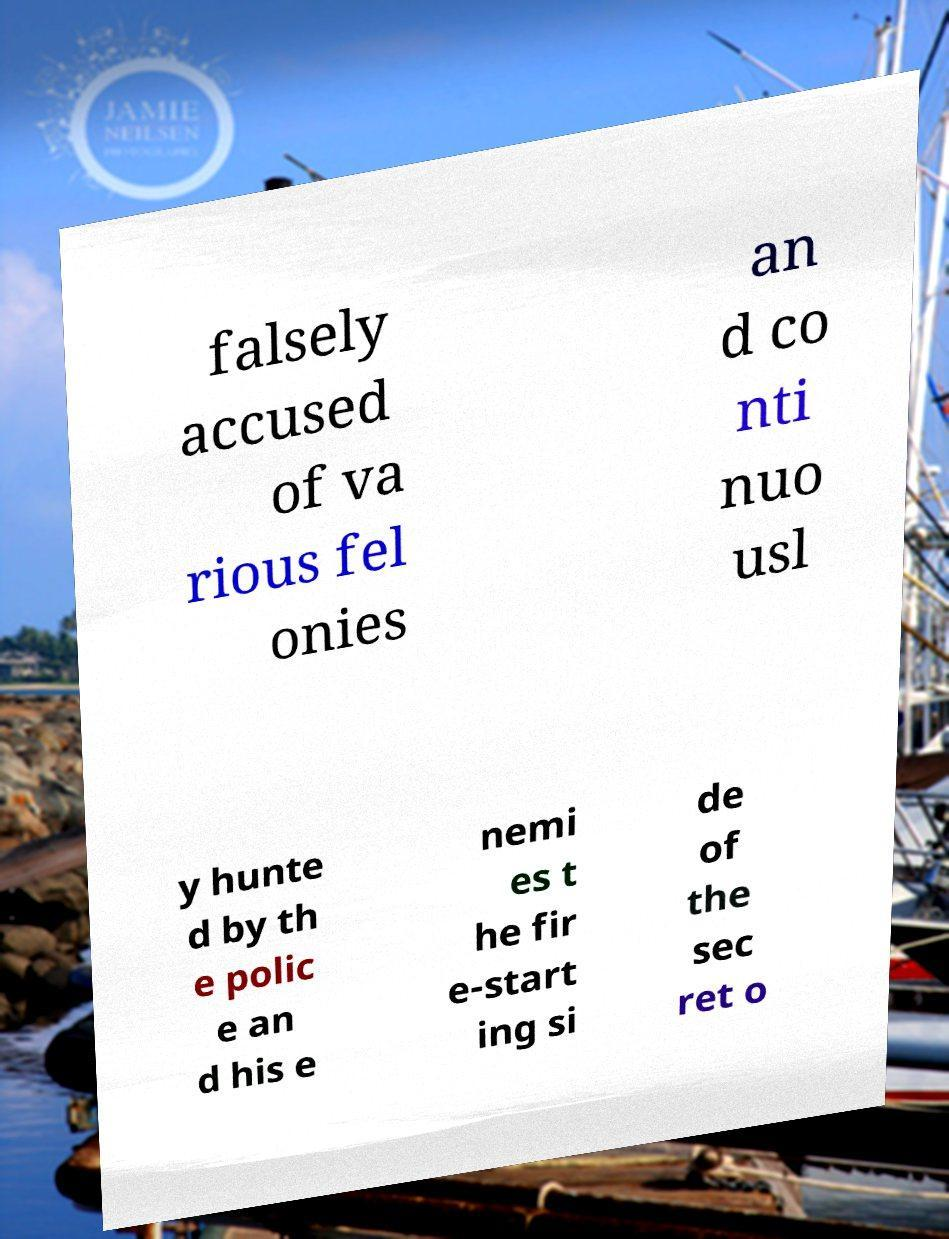Could you extract and type out the text from this image? falsely accused of va rious fel onies an d co nti nuo usl y hunte d by th e polic e an d his e nemi es t he fir e-start ing si de of the sec ret o 